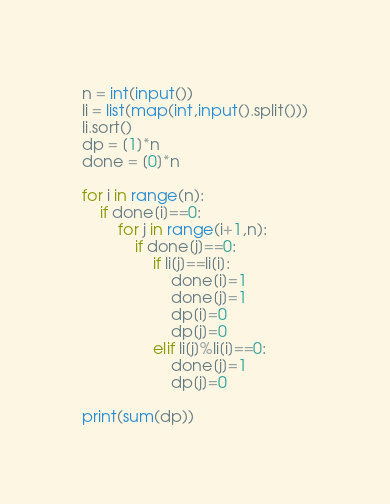<code> <loc_0><loc_0><loc_500><loc_500><_Python_>n = int(input())
li = list(map(int,input().split()))
li.sort()
dp = [1]*n
done = [0]*n

for i in range(n):
    if done[i]==0:
        for j in range(i+1,n):
            if done[j]==0:
                if li[j]==li[i]:
                    done[i]=1
                    done[j]=1
                    dp[i]=0
                    dp[j]=0
                elif li[j]%li[i]==0:
                    done[j]=1
                    dp[j]=0

print(sum(dp))</code> 